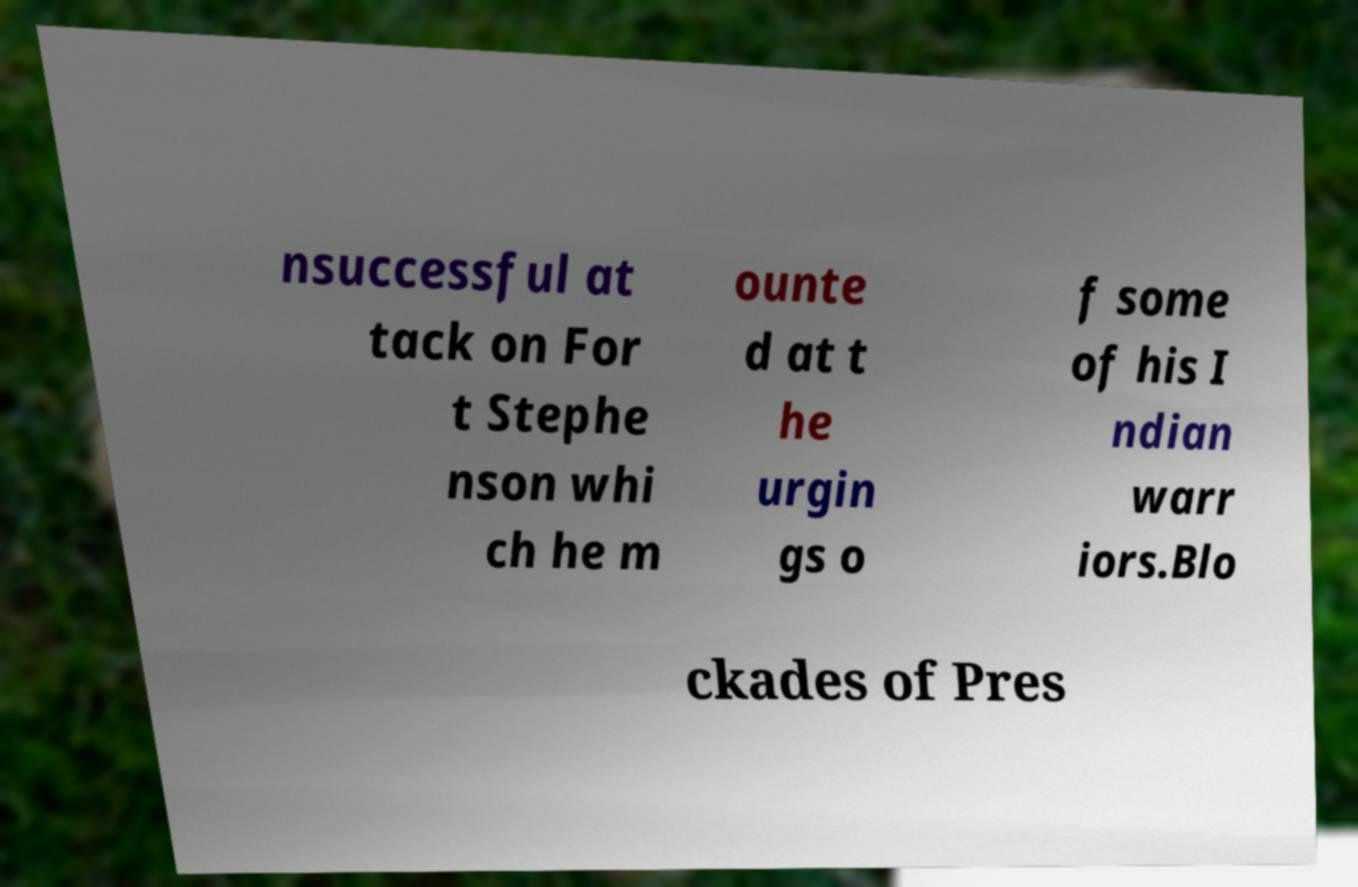For documentation purposes, I need the text within this image transcribed. Could you provide that? nsuccessful at tack on For t Stephe nson whi ch he m ounte d at t he urgin gs o f some of his I ndian warr iors.Blo ckades of Pres 